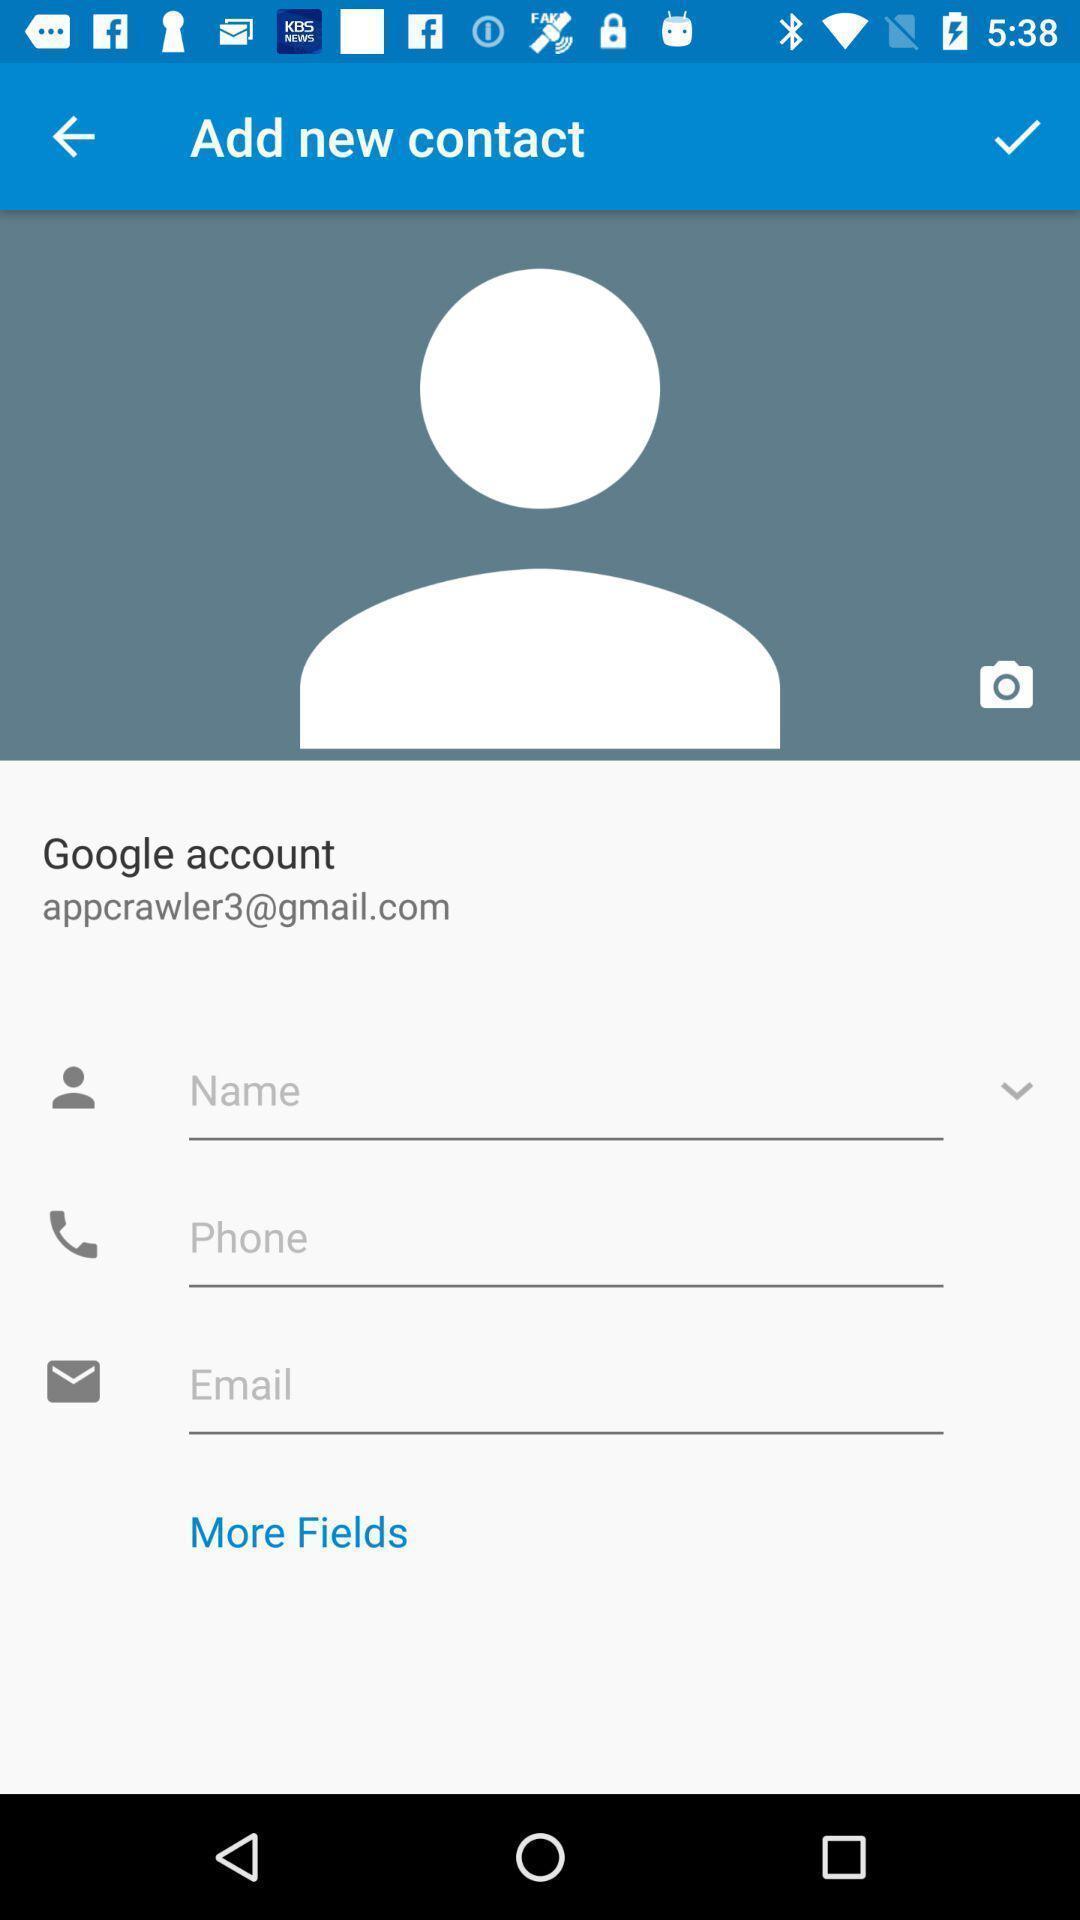Summarize the main components in this picture. Screen displaying multiple options in user account page. 